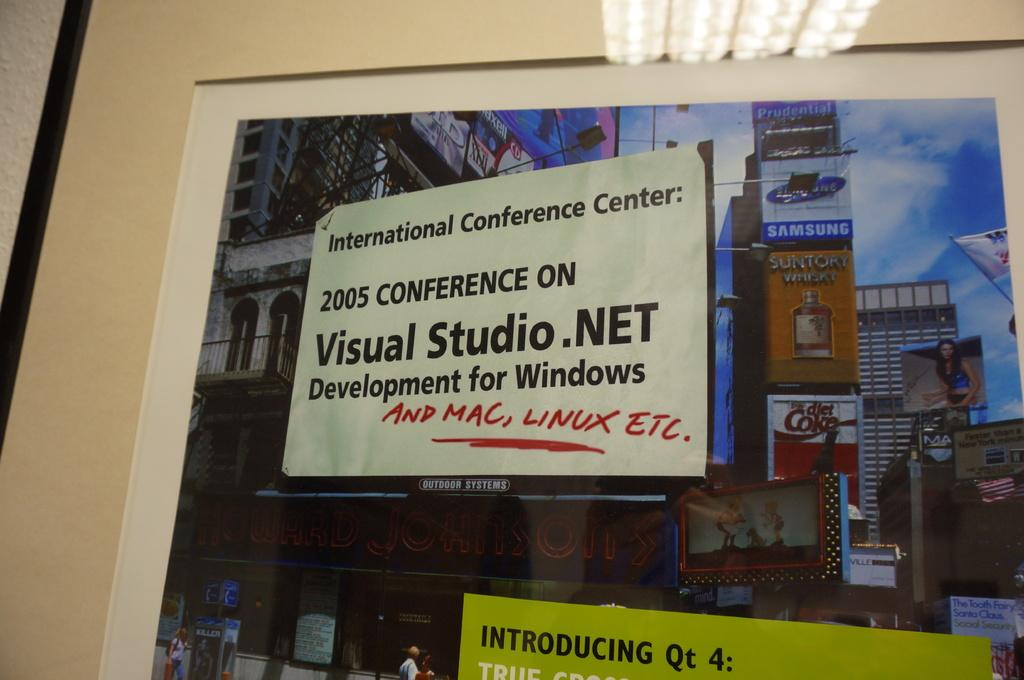Provide a one-sentence caption for the provided image. a sign from the visual stuio . net. 